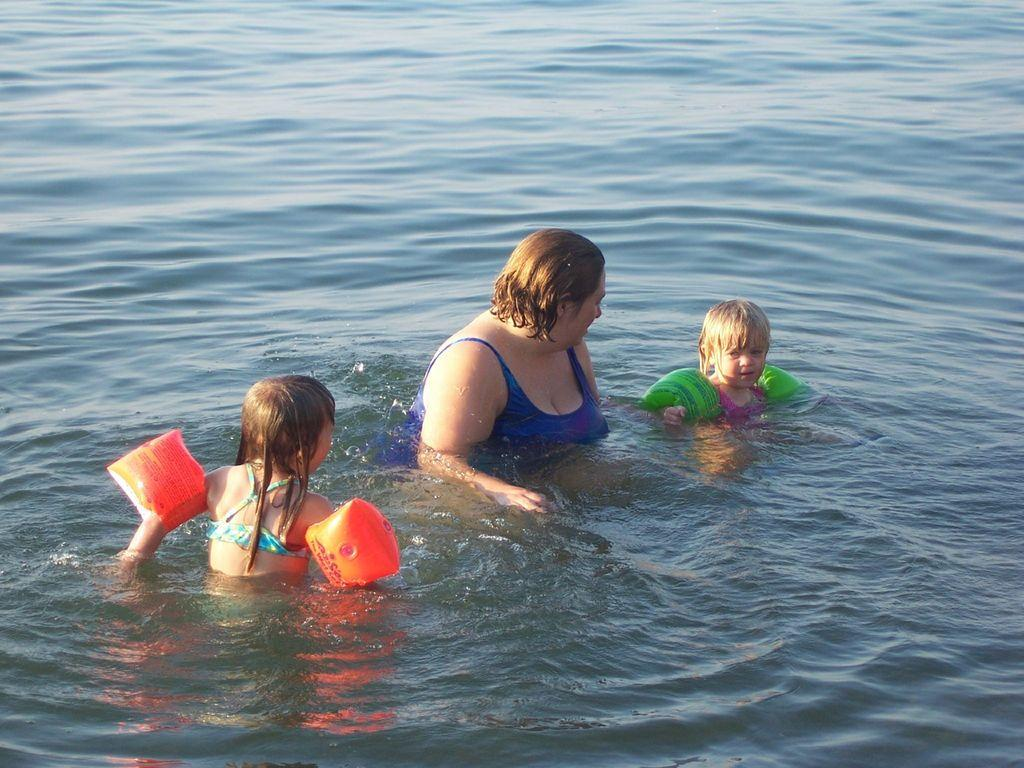Who is present in the image? There is a woman and two children in the image. What are the children holding in the image? The children are holding balloons in the image. Where are the woman and children located in the image? The woman and children are in the water in the image. What is the woman doing in the image? The woman is looking at the child on the right side in the image. What type of gun can be seen in the image? There is no gun present in the image. What is the woman using to cook in the image? There is no pan or cooking activity present in the image. 